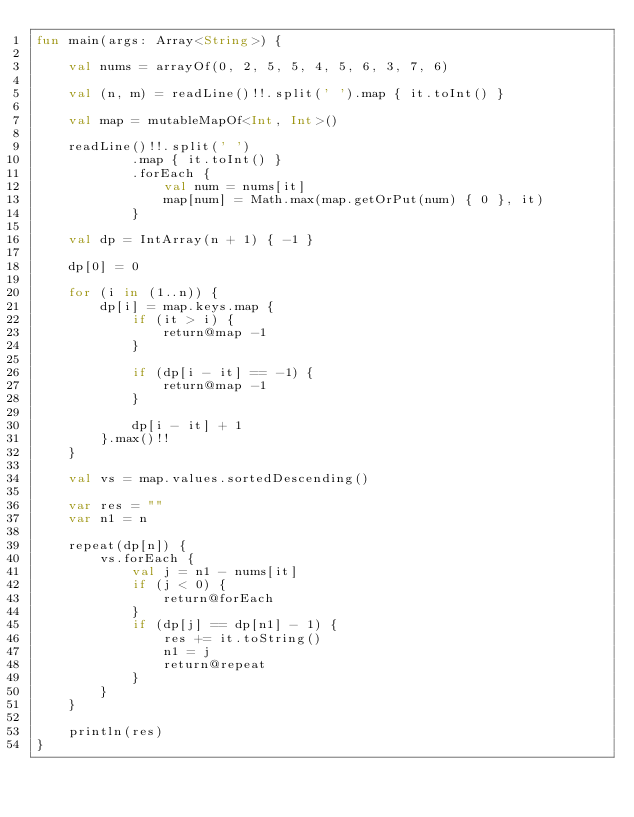Convert code to text. <code><loc_0><loc_0><loc_500><loc_500><_Kotlin_>fun main(args: Array<String>) {

    val nums = arrayOf(0, 2, 5, 5, 4, 5, 6, 3, 7, 6)

    val (n, m) = readLine()!!.split(' ').map { it.toInt() }

    val map = mutableMapOf<Int, Int>()

    readLine()!!.split(' ')
            .map { it.toInt() }
            .forEach {
                val num = nums[it]
                map[num] = Math.max(map.getOrPut(num) { 0 }, it)
            }

    val dp = IntArray(n + 1) { -1 }

    dp[0] = 0

    for (i in (1..n)) {
        dp[i] = map.keys.map {
            if (it > i) {
                return@map -1
            }

            if (dp[i - it] == -1) {
                return@map -1
            }

            dp[i - it] + 1
        }.max()!!
    }

    val vs = map.values.sortedDescending()

    var res = ""
    var n1 = n

    repeat(dp[n]) {
        vs.forEach {
            val j = n1 - nums[it]
            if (j < 0) {
                return@forEach
            }
            if (dp[j] == dp[n1] - 1) {
                res += it.toString()
                n1 = j
                return@repeat
            }
        }
    }

    println(res)
}
</code> 